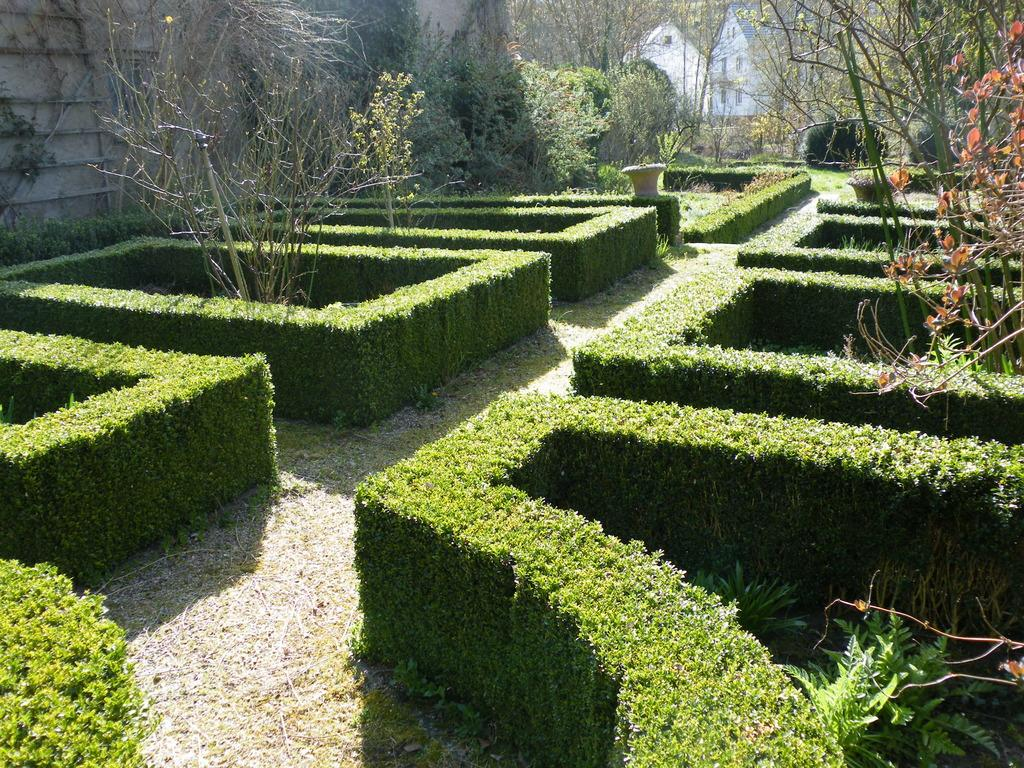What type of structure is present in the image? There is a garden maze in the image. What type of vegetation can be seen in the image? There are trees and shrubs in the image. What type of man-made structures are present in the image? There are walls and buildings in the image. What type of shoe can be seen hanging from the tree in the image? There is no shoe hanging from the tree in the image; only trees, shrubs, walls, and buildings are present. 